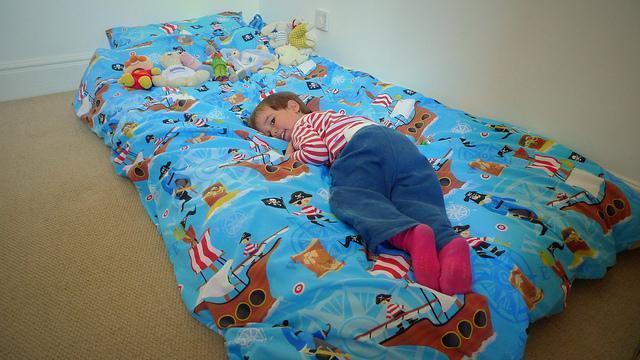Who is joining the boy on his bed?
Select the accurate response from the four choices given to answer the question.
Options: Parents, siblings, dogs, stuffed animals. Stuffed animals. The boy is wearing a shirt that looks like the shirt of a character in what series?
Choose the correct response, then elucidate: 'Answer: answer
Rationale: rationale.'
Options: Smurfs, curious george, where's waldo, garfield. Answer: where's waldo.
Rationale: A kid is wearing a red and white striped shirt. 